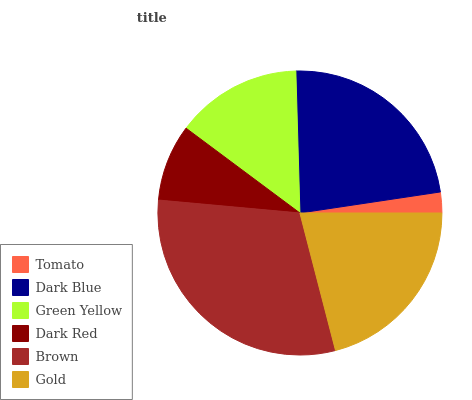Is Tomato the minimum?
Answer yes or no. Yes. Is Brown the maximum?
Answer yes or no. Yes. Is Dark Blue the minimum?
Answer yes or no. No. Is Dark Blue the maximum?
Answer yes or no. No. Is Dark Blue greater than Tomato?
Answer yes or no. Yes. Is Tomato less than Dark Blue?
Answer yes or no. Yes. Is Tomato greater than Dark Blue?
Answer yes or no. No. Is Dark Blue less than Tomato?
Answer yes or no. No. Is Gold the high median?
Answer yes or no. Yes. Is Green Yellow the low median?
Answer yes or no. Yes. Is Green Yellow the high median?
Answer yes or no. No. Is Tomato the low median?
Answer yes or no. No. 